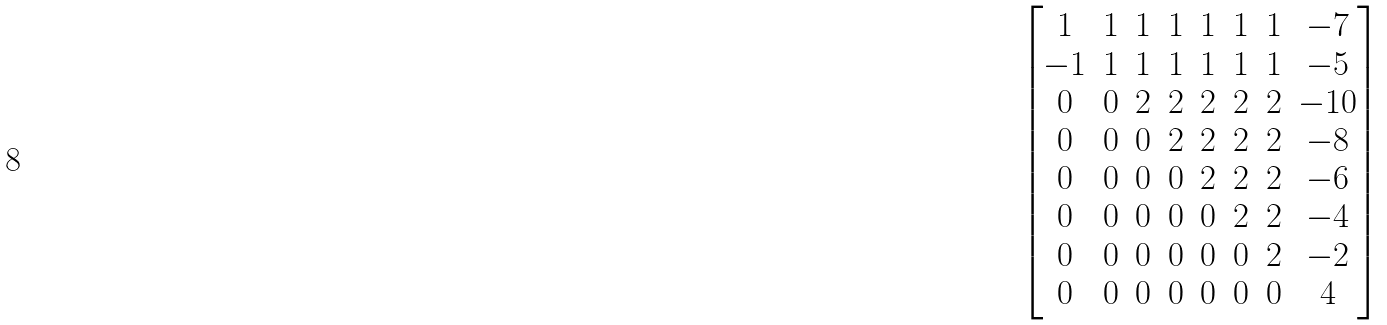<formula> <loc_0><loc_0><loc_500><loc_500>\begin{bmatrix} 1 & 1 & 1 & 1 & 1 & 1 & 1 & - 7 \\ - 1 & 1 & 1 & 1 & 1 & 1 & 1 & - 5 \\ 0 & 0 & 2 & 2 & 2 & 2 & 2 & - 1 0 \\ 0 & 0 & 0 & 2 & 2 & 2 & 2 & - 8 \\ 0 & 0 & 0 & 0 & 2 & 2 & 2 & - 6 \\ 0 & 0 & 0 & 0 & 0 & 2 & 2 & - 4 \\ 0 & 0 & 0 & 0 & 0 & 0 & 2 & - 2 \\ 0 & 0 & 0 & 0 & 0 & 0 & 0 & 4 \\ \end{bmatrix}</formula> 